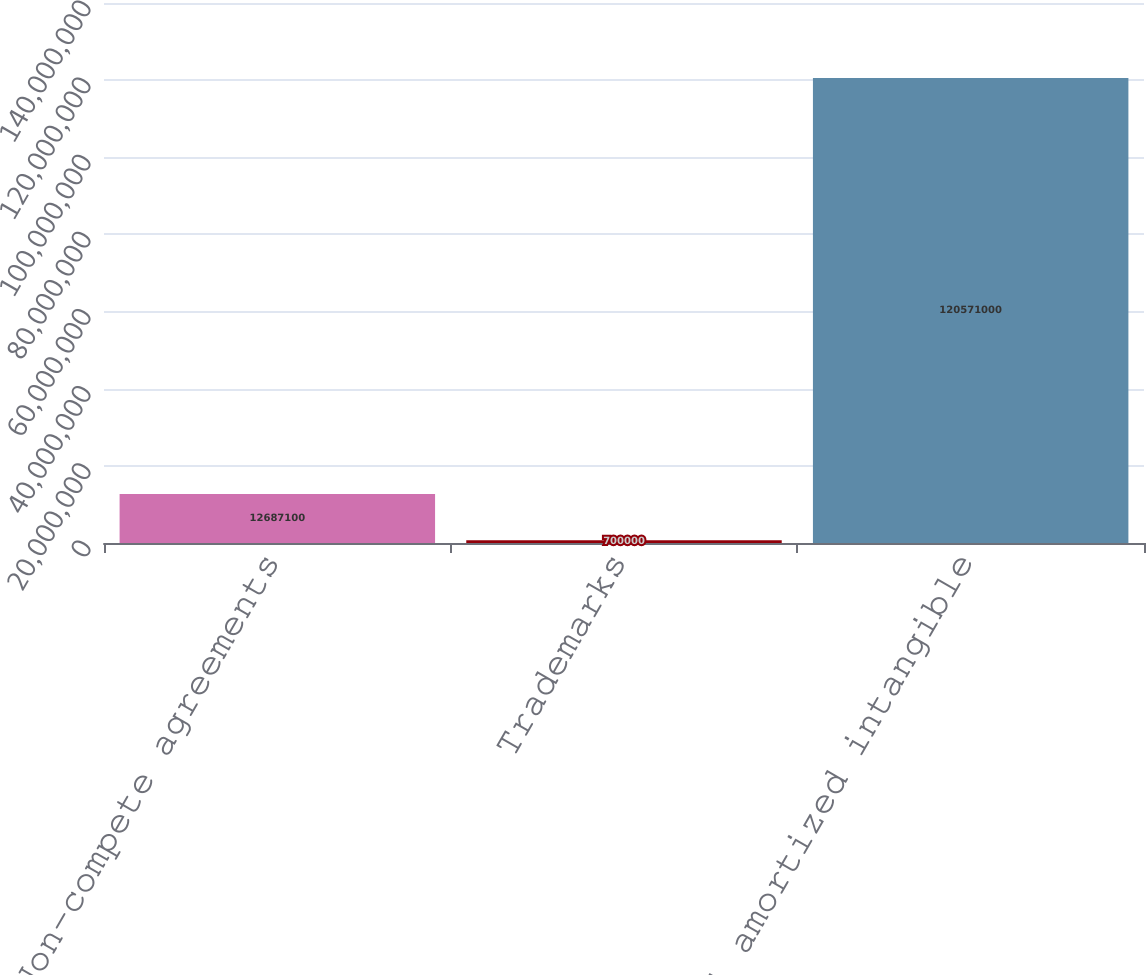<chart> <loc_0><loc_0><loc_500><loc_500><bar_chart><fcel>Non-compete agreements<fcel>Trademarks<fcel>Total amortized intangible<nl><fcel>1.26871e+07<fcel>700000<fcel>1.20571e+08<nl></chart> 